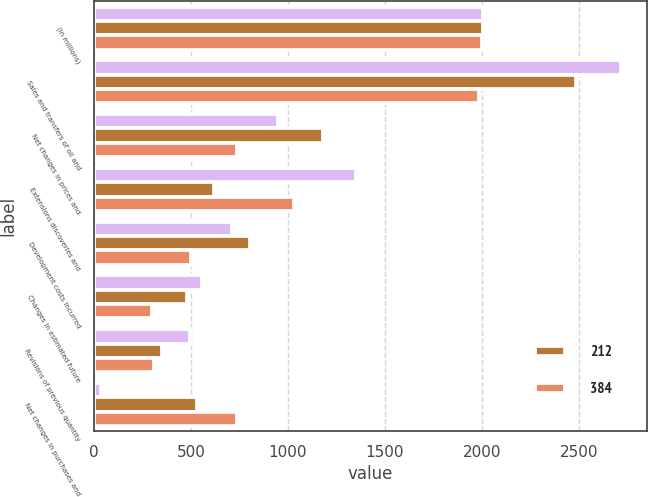Convert chart. <chart><loc_0><loc_0><loc_500><loc_500><stacked_bar_chart><ecel><fcel>(In millions)<fcel>Sales and transfers of oil and<fcel>Net changes in prices and<fcel>Extensions discoveries and<fcel>Development costs incurred<fcel>Changes in estimated future<fcel>Revisions of previous quantity<fcel>Net changes in purchases and<nl><fcel>nan<fcel>2004<fcel>2715<fcel>950<fcel>1352<fcel>711<fcel>556<fcel>494<fcel>33<nl><fcel>212<fcel>2003<fcel>2487<fcel>1178<fcel>618<fcel>802<fcel>478<fcel>348<fcel>531<nl><fcel>384<fcel>2002<fcel>1983<fcel>737<fcel>1032<fcel>499<fcel>297<fcel>311<fcel>737<nl></chart> 